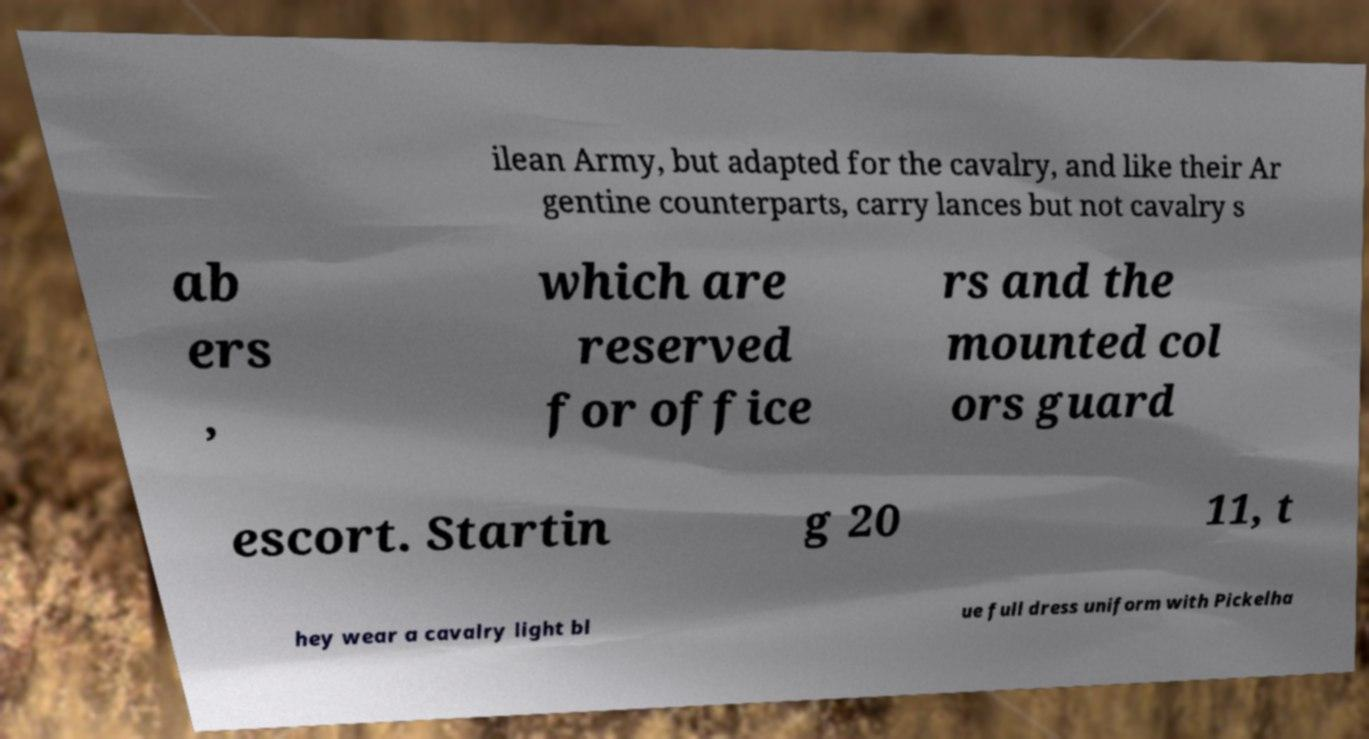What messages or text are displayed in this image? I need them in a readable, typed format. ilean Army, but adapted for the cavalry, and like their Ar gentine counterparts, carry lances but not cavalry s ab ers , which are reserved for office rs and the mounted col ors guard escort. Startin g 20 11, t hey wear a cavalry light bl ue full dress uniform with Pickelha 